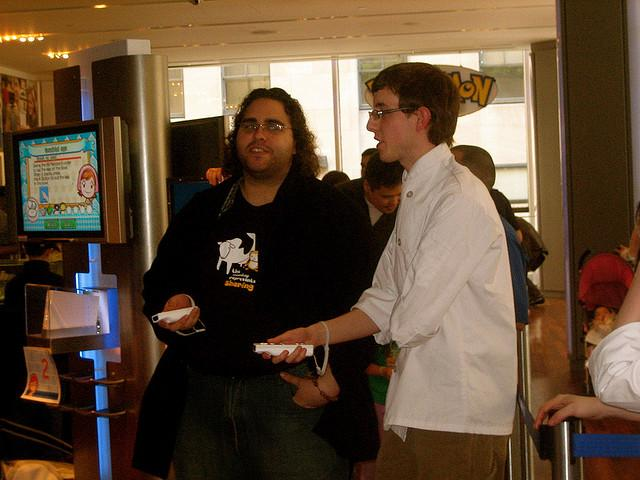What major gaming franchise is being advertised on the window?

Choices:
A) pokemon
B) twin peaks
C) ghostbusters
D) mask pokemon 